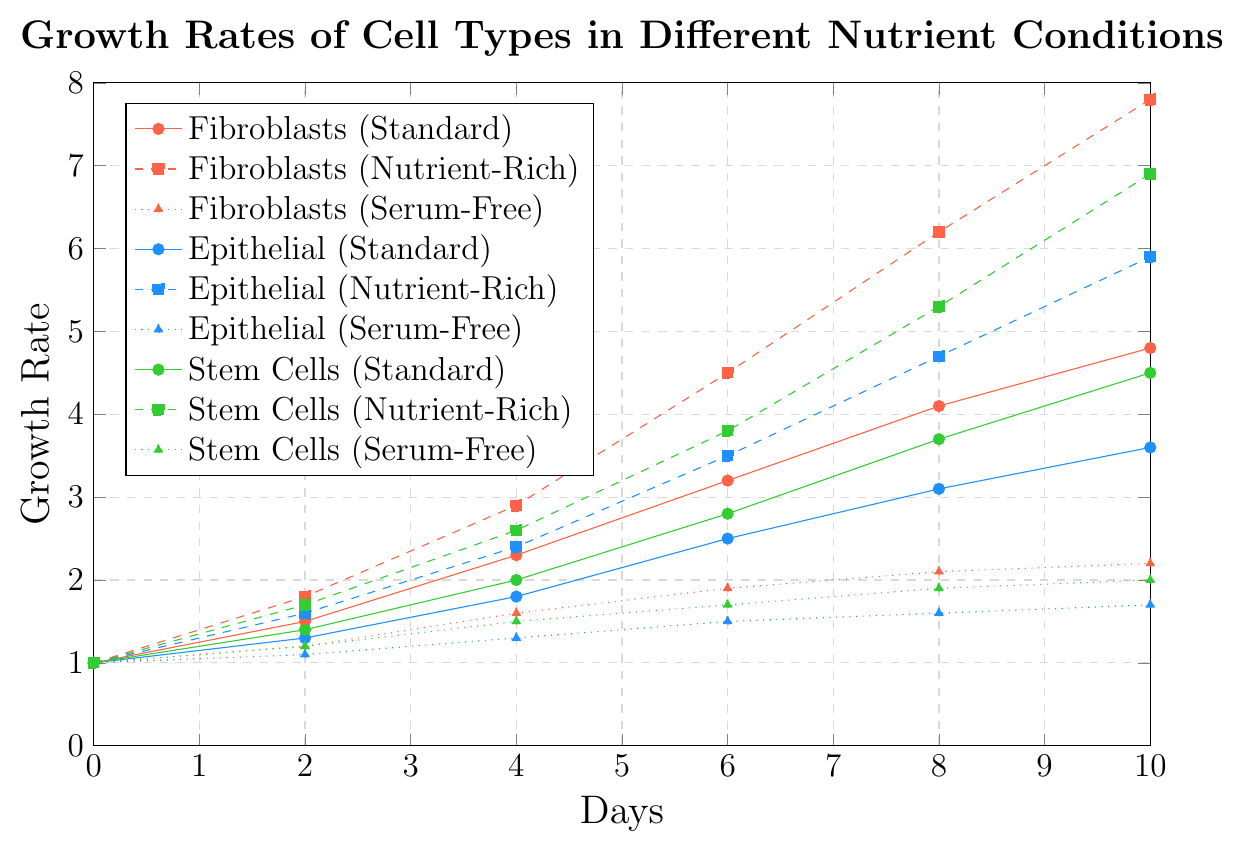Which cell type shows the highest growth rate under the nutrient-rich condition at Day 10? To find the cell type with the highest growth rate under the nutrient-rich condition at Day 10, look for the highest value among the nutrient-rich growth rates. The values are 7.8 for Fibroblasts, 5.9 for Epithelial Cells, and 6.9 for Stem Cells. The highest value is 7.8 for Fibroblasts.
Answer: Fibroblasts What is the difference in growth rates between Fibroblasts and Epithelial Cells in Serum-Free Medium at Day 8? To calculate the difference, find the growth rates for both cell types in Serum-Free Medium at Day 8. Fibroblasts have a growth rate of 2.1, and Epithelial Cells have a growth rate of 1.6. The difference is 2.1 - 1.6 = 0.5.
Answer: 0.5 Compare the growth rates of Stem Cells in Standard and Nutrient-Rich Mediums at Day 6. Which one is higher? At Day 6, the growth rate for Stem Cells in Standard Medium is 2.8, while in Nutrient-Rich Medium, it is 3.8. Comparing these values, 3.8 is higher.
Answer: Nutrient-Rich Medium Which cell type has the smallest growth rate at Day 4 in Serum-Free Medium? At Day 4, the growth rates in Serum-Free Medium for the cell types are Fibroblasts (1.6), Epithelial Cells (1.3), and Stem Cells (1.5). The smallest value is 1.3 for Epithelial Cells.
Answer: Epithelial Cells What's the average growth rate of Fibroblasts in Nutrient-Rich Medium from Day 0 to Day 10? To find the average, sum up the growth rates at each recorded day and divide by the number of days. The growth rates are 1.0, 1.8, 2.9, 4.5, 6.2, 7.8. Sum: 1.0 + 1.8 + 2.9 + 4.5 + 6.2 + 7.8 = 24.2. Average: 24.2 / 6 = 4.0333.
Answer: 4.0333 Identify the cell type with the fastest increasing growth rate in Standard Medium from Day 4 to Day 6. Calculate the difference in growth rates from Day 4 to Day 6 for each cell type in Standard Medium. Fibroblasts: 3.2 - 2.3 = 0.9, Epithelial Cells: 2.5 - 1.8 = 0.7, Stem Cells: 2.8 - 2.0 = 0.8. The fastest increase is 0.9 for Fibroblasts.
Answer: Fibroblasts What’s the total growth of Epithelial Cells in Nutrient-Rich Medium from Day 0 to Day 10? Sum up the growth rates at each recorded day. The values are 1.0, 1.6, 2.4, 3.5, 4.7, 5.9. Sum: 1.0 + 1.6 + 2.4 + 3.5 + 4.7 + 5.9 = 19.1.
Answer: 19.1 How does the growth rate of Stem Cells in Serum-Free Medium compare to that in Standard Medium at Day 10? At Day 10, the growth rate of Stem Cells in Serum-Free Medium is 2.0, while in Standard Medium, it is 4.5. So, the Standard Medium has a higher growth rate by 2.5 (4.5 - 2.0).
Answer: Standard Medium is higher by 2.5 Which cell type in Standard Medium shows growth close to Stem Cells in Nutrient-Rich Medium at Day 8? At Day 8, the growth rate of Stem Cells in Nutrient-Rich Medium is 5.3. Comparing with Standard Medium growth rates: Fibroblasts (4.1), Epithelial Cells (3.1), and Stem Cells (3.7). The closest value is Fibroblasts with 4.1.
Answer: Fibroblasts 